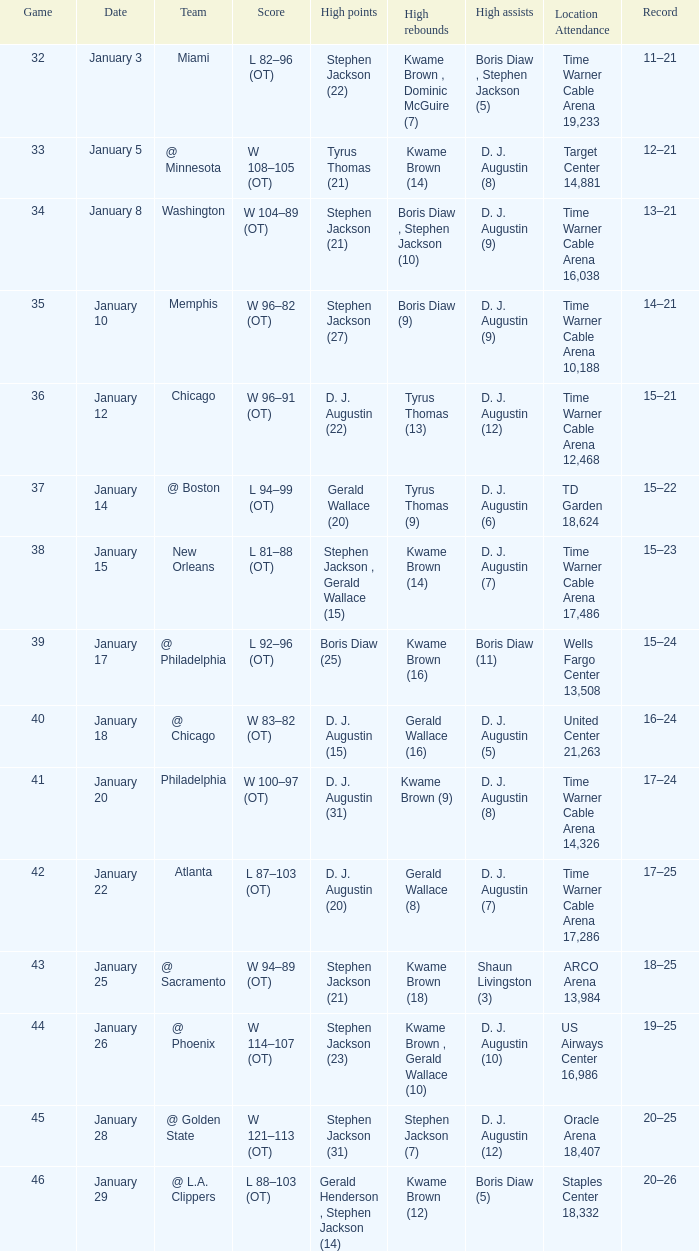How many high rebounds are listed for game 35? 1.0. 